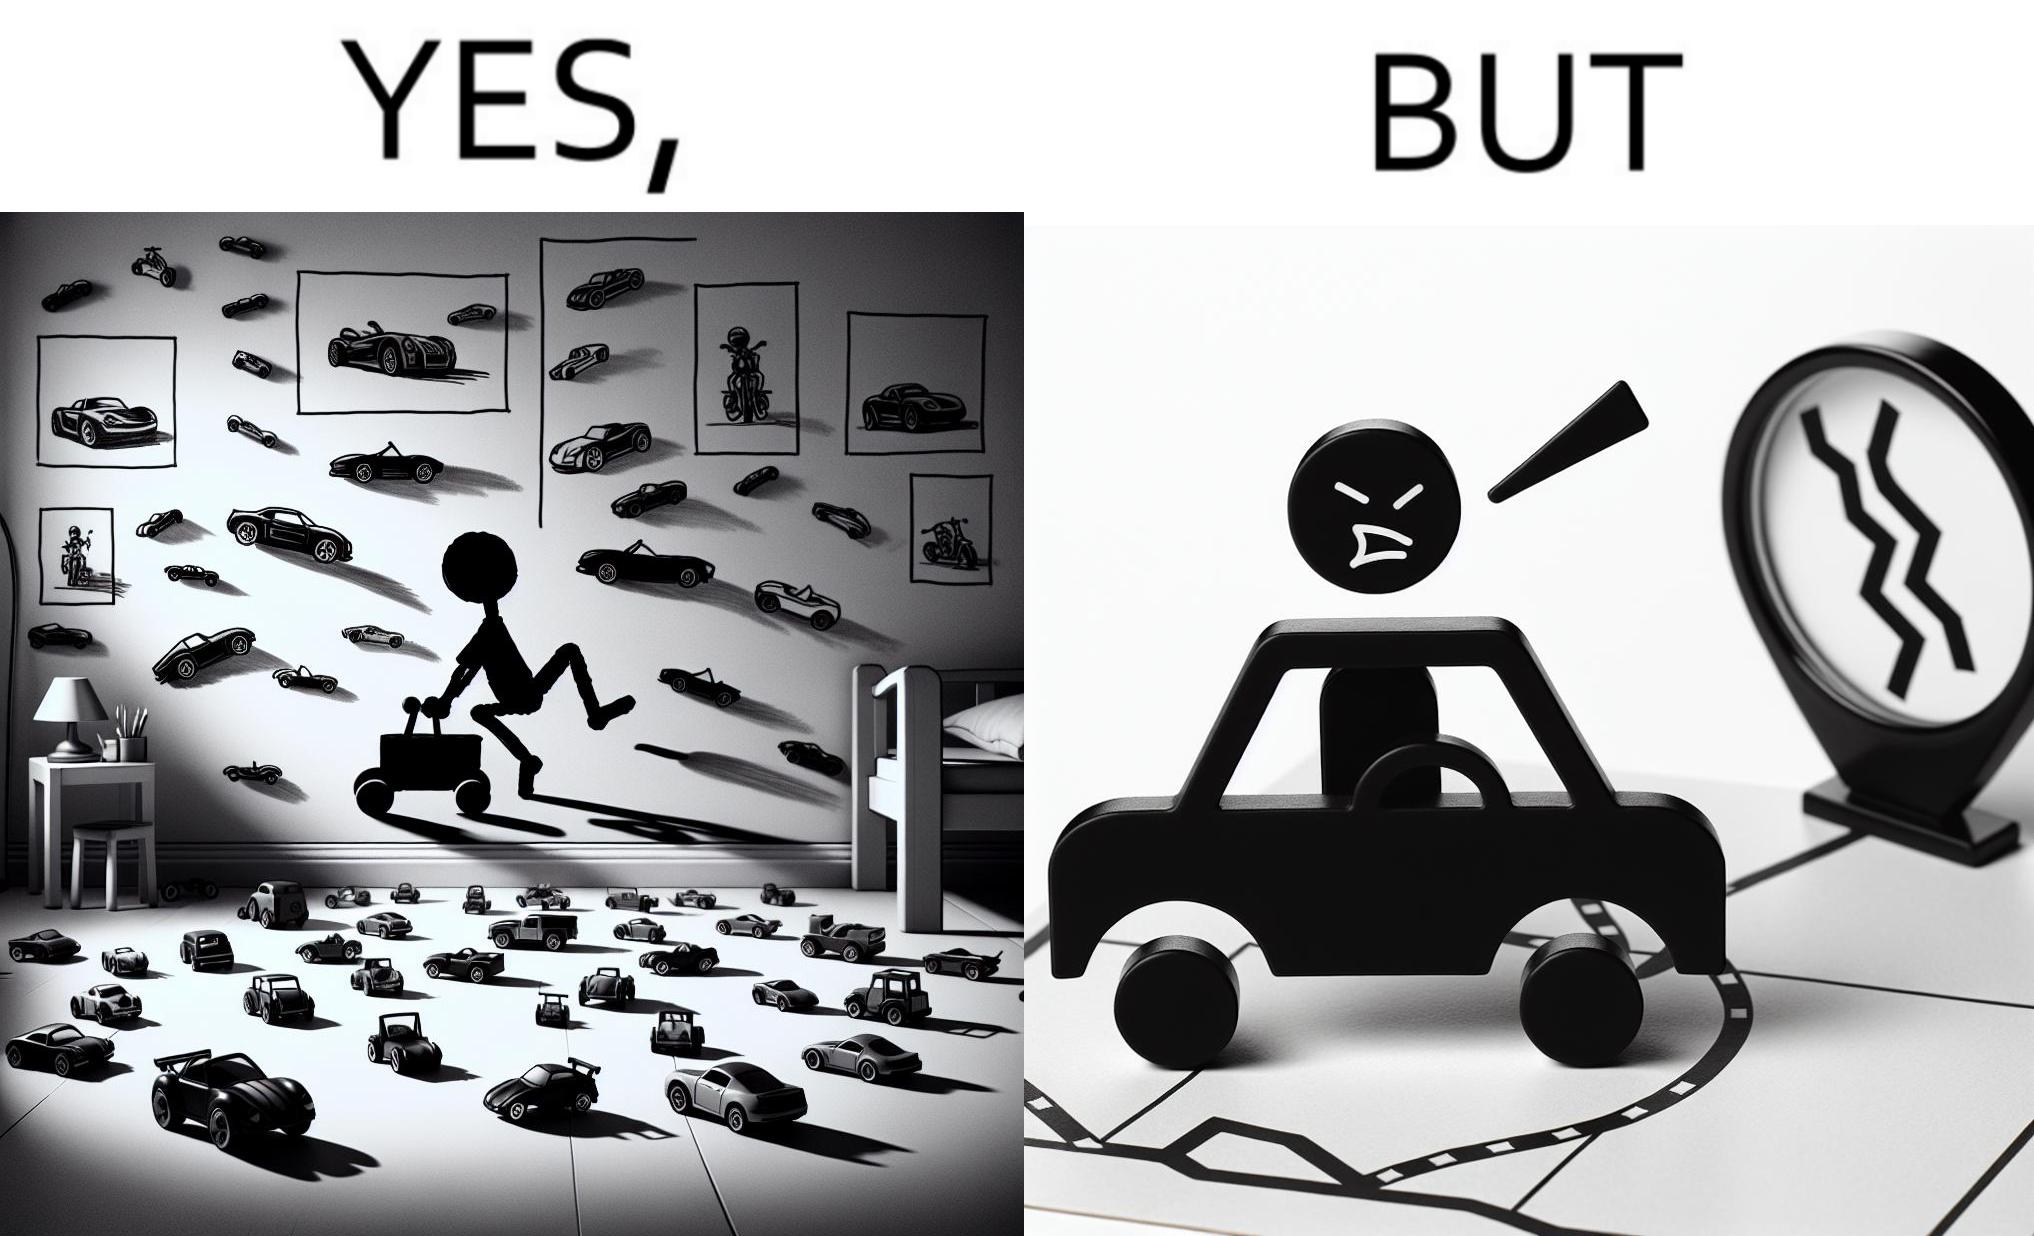What makes this image funny or satirical? The image is funny beaucse while the person as a child enjoyed being around cars, had various small toy cars and even rode a bigger toy car, as as grown up he does not enjoy being in a car during a traffic jam while he is driving . 